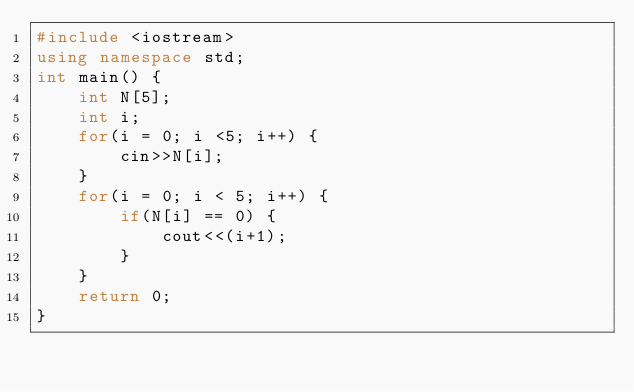<code> <loc_0><loc_0><loc_500><loc_500><_C++_>#include <iostream>
using namespace std;
int main() {
	int N[5];
	int i;
	for(i = 0; i <5; i++) {
		cin>>N[i];
	}
	for(i = 0; i < 5; i++) {
		if(N[i] == 0) {
			cout<<(i+1);
		}
	}
	return 0;
}
</code> 